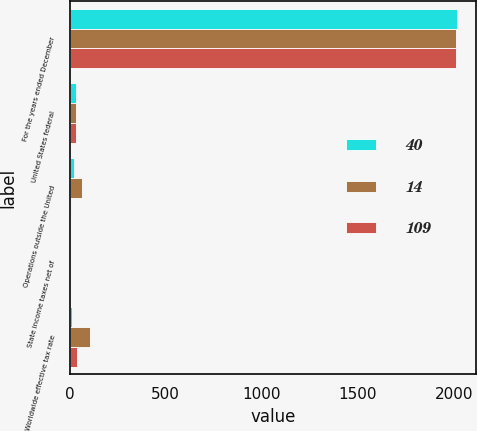<chart> <loc_0><loc_0><loc_500><loc_500><stacked_bar_chart><ecel><fcel>For the years ended December<fcel>United States federal<fcel>Operations outside the United<fcel>State income taxes net of<fcel>Worldwide effective tax rate<nl><fcel>40<fcel>2015<fcel>35<fcel>21<fcel>1<fcel>14<nl><fcel>14<fcel>2014<fcel>35<fcel>65<fcel>1<fcel>109<nl><fcel>109<fcel>2013<fcel>35<fcel>5<fcel>1<fcel>40<nl></chart> 